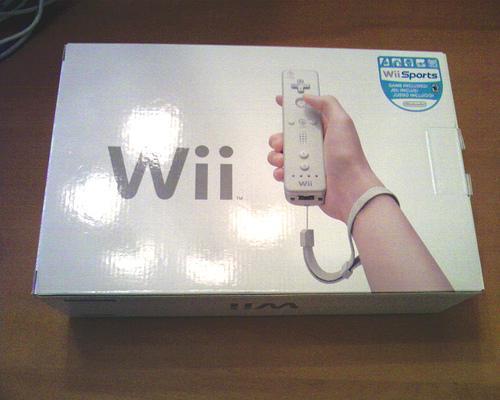How many arms are inside the box?
Give a very brief answer. 0. 